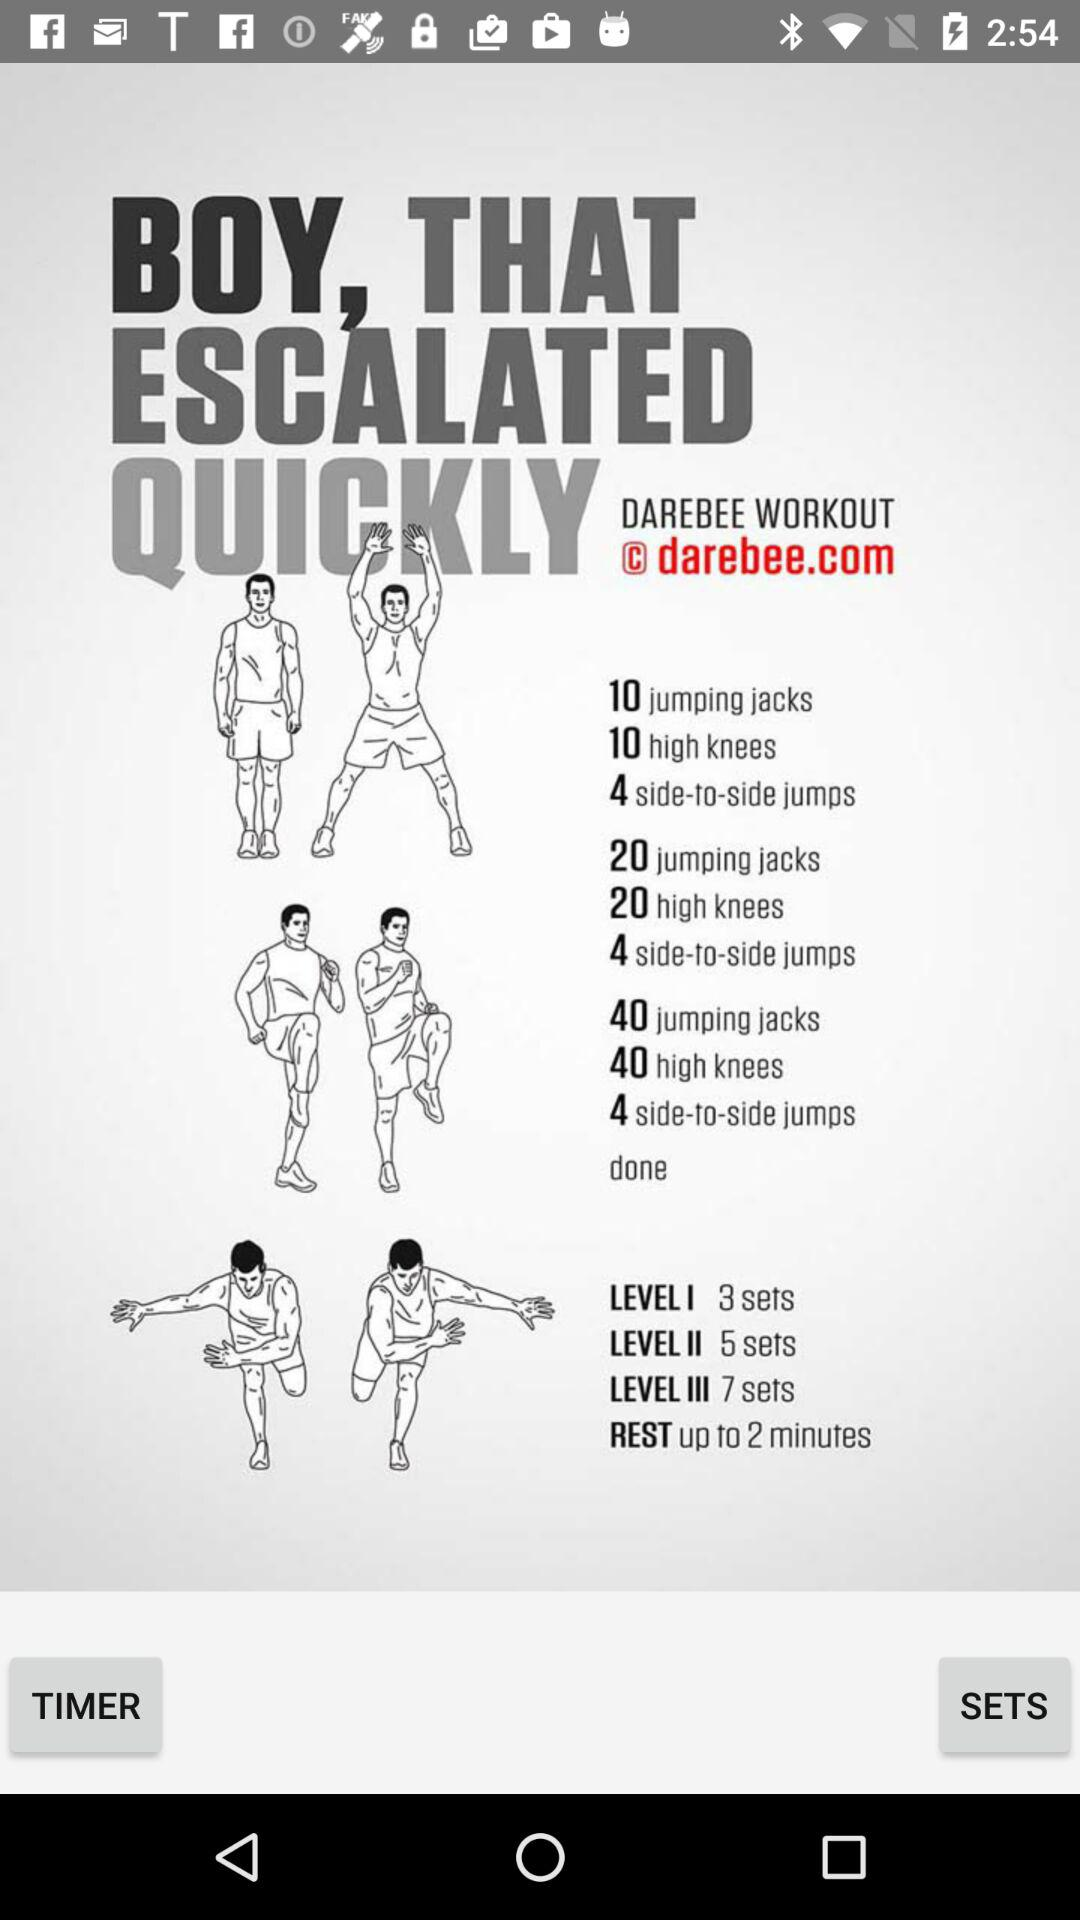What's the email address?
When the provided information is insufficient, respond with <no answer>. <no answer> 